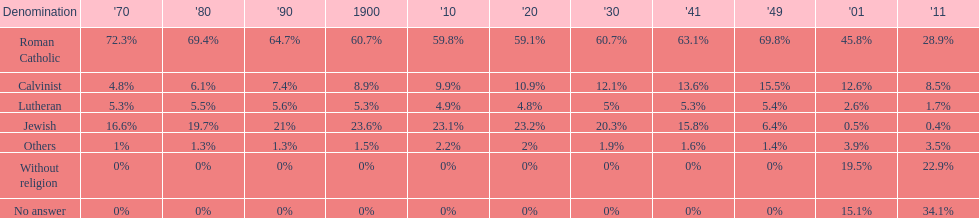Which denomination held the largest percentage in 1880? Roman Catholic. 